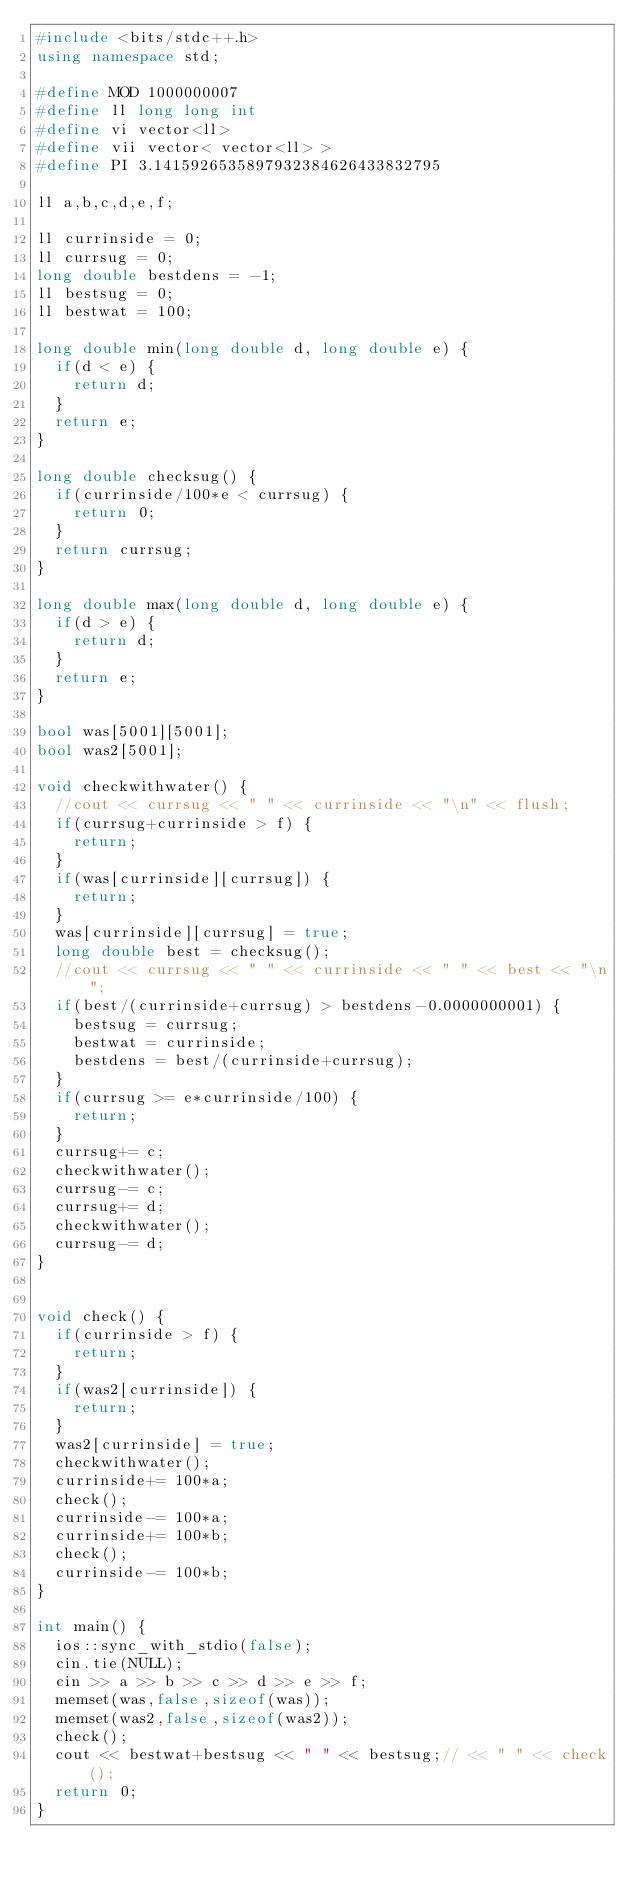Convert code to text. <code><loc_0><loc_0><loc_500><loc_500><_C++_>#include <bits/stdc++.h>
using namespace std;

#define MOD 1000000007
#define ll long long int
#define vi vector<ll>
#define vii vector< vector<ll> >
#define PI 3.1415926535897932384626433832795

ll a,b,c,d,e,f;

ll currinside = 0;
ll currsug = 0;
long double bestdens = -1;
ll bestsug = 0;
ll bestwat = 100;

long double min(long double d, long double e) {
	if(d < e) {
		return d;
	}
	return e;
}

long double checksug() {
	if(currinside/100*e < currsug) {
		return 0;
	}
	return currsug;
}

long double max(long double d, long double e) {
	if(d > e) {
		return d;
	}
	return e;
}

bool was[5001][5001];
bool was2[5001];

void checkwithwater() {
	//cout << currsug << " " << currinside << "\n" << flush;
	if(currsug+currinside > f) {
		return;
	}
	if(was[currinside][currsug]) {
		return;
	}
	was[currinside][currsug] = true;
	long double best = checksug();
	//cout << currsug << " " << currinside << " " << best << "\n";
	if(best/(currinside+currsug) > bestdens-0.0000000001) {
		bestsug = currsug;
		bestwat = currinside;
		bestdens = best/(currinside+currsug);
	}
	if(currsug >= e*currinside/100) {
		return;
	}
	currsug+= c;
	checkwithwater();
	currsug-= c;
	currsug+= d;
	checkwithwater();
	currsug-= d;
}


void check() {
	if(currinside > f) {
		return;
	}
	if(was2[currinside]) {
		return;
	}
	was2[currinside] = true;
	checkwithwater();
	currinside+= 100*a;
	check();
	currinside-= 100*a;
	currinside+= 100*b;
	check();
	currinside-= 100*b;
}

int main() {
	ios::sync_with_stdio(false);
	cin.tie(NULL);
	cin >> a >> b >> c >> d >> e >> f;
	memset(was,false,sizeof(was));
	memset(was2,false,sizeof(was2));
	check();
	cout << bestwat+bestsug << " " << bestsug;// << " " << check();
	return 0;
}

</code> 